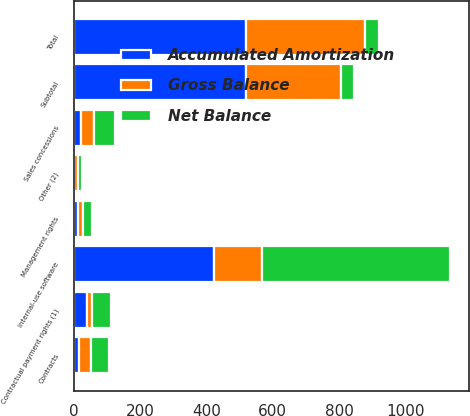Convert chart to OTSL. <chart><loc_0><loc_0><loc_500><loc_500><stacked_bar_chart><ecel><fcel>Internal-use software<fcel>Sales concessions<fcel>Contractual payment rights (1)<fcel>Management rights<fcel>Contracts<fcel>Other (2)<fcel>Subtotal<fcel>Total<nl><fcel>Net Balance<fcel>567<fcel>63<fcel>56<fcel>28<fcel>53<fcel>12<fcel>41.5<fcel>41.5<nl><fcel>Accumulated Amortization<fcel>424<fcel>22<fcel>42<fcel>13<fcel>15<fcel>2<fcel>519<fcel>519<nl><fcel>Gross Balance<fcel>143<fcel>41<fcel>14<fcel>15<fcel>38<fcel>10<fcel>285<fcel>359<nl></chart> 